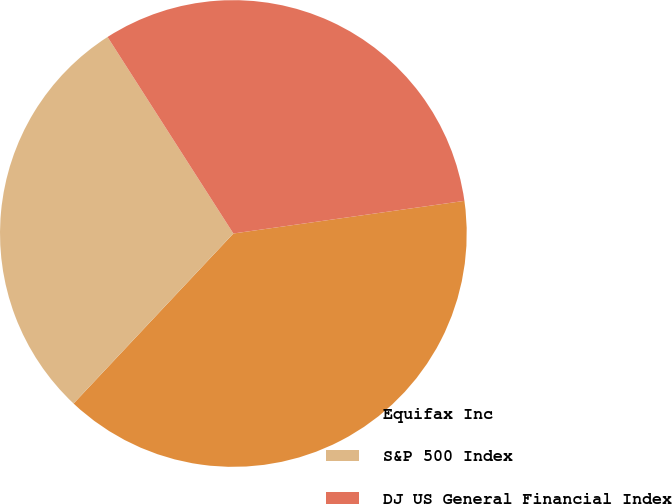Convert chart. <chart><loc_0><loc_0><loc_500><loc_500><pie_chart><fcel>Equifax Inc<fcel>S&P 500 Index<fcel>DJ US General Financial Index<nl><fcel>39.24%<fcel>28.93%<fcel>31.83%<nl></chart> 